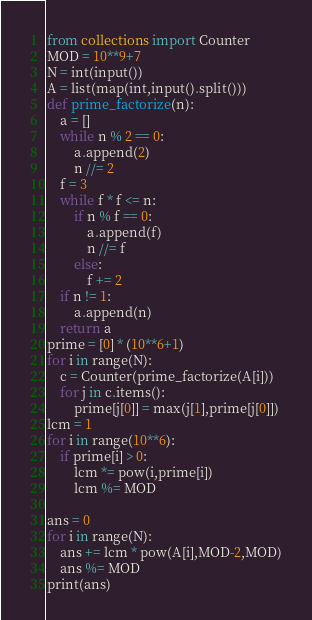Convert code to text. <code><loc_0><loc_0><loc_500><loc_500><_Python_>from collections import Counter
MOD = 10**9+7
N = int(input())
A = list(map(int,input().split()))
def prime_factorize(n):
    a = []
    while n % 2 == 0:
        a.append(2)
        n //= 2
    f = 3
    while f * f <= n:
        if n % f == 0:
            a.append(f)
            n //= f
        else:
            f += 2
    if n != 1:
        a.append(n)
    return a
prime = [0] * (10**6+1)
for i in range(N):
    c = Counter(prime_factorize(A[i]))
    for j in c.items():
        prime[j[0]] = max(j[1],prime[j[0]])
lcm = 1
for i in range(10**6):
    if prime[i] > 0:
        lcm *= pow(i,prime[i])
        lcm %= MOD

ans = 0
for i in range(N):
    ans += lcm * pow(A[i],MOD-2,MOD)
    ans %= MOD
print(ans)
</code> 